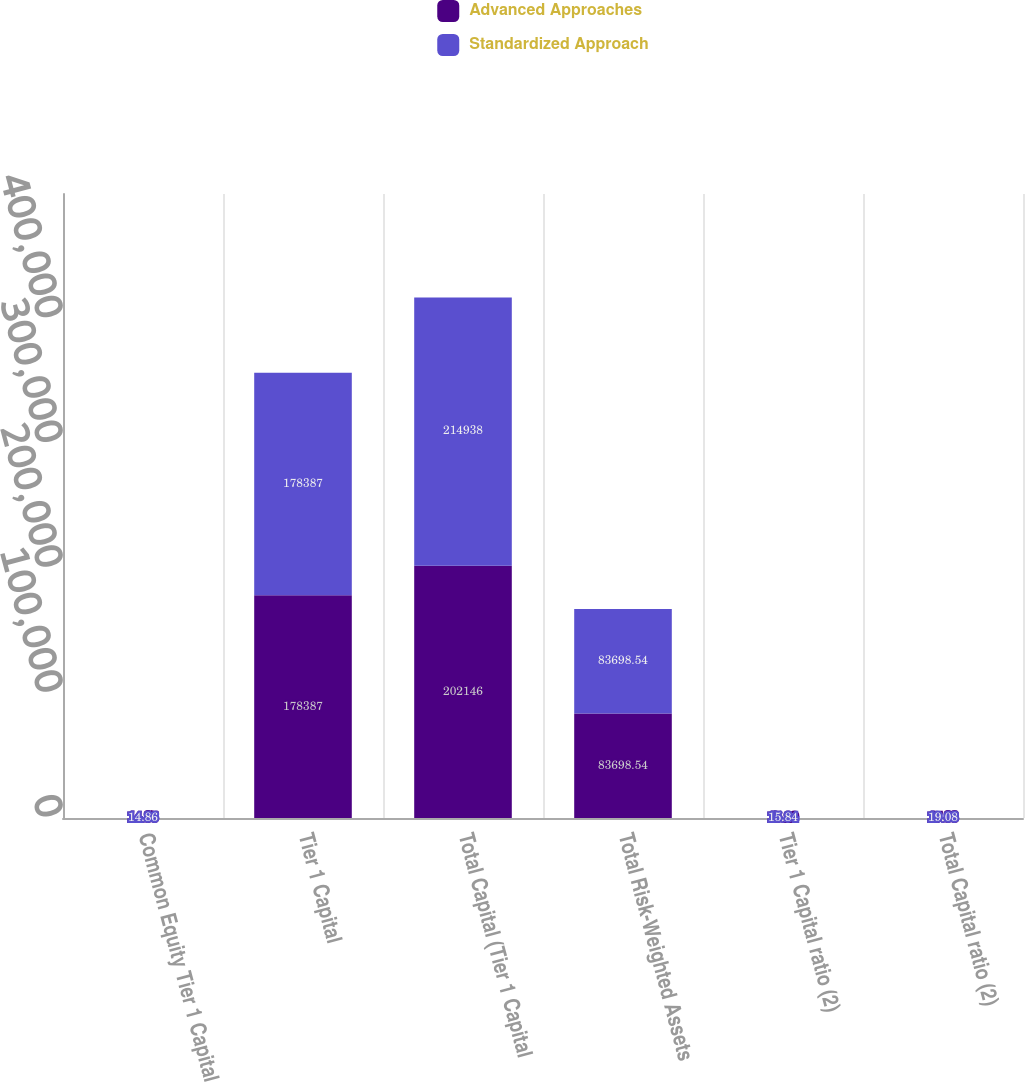<chart> <loc_0><loc_0><loc_500><loc_500><stacked_bar_chart><ecel><fcel>Common Equity Tier 1 Capital<fcel>Tier 1 Capital<fcel>Total Capital (Tier 1 Capital<fcel>Total Risk-Weighted Assets<fcel>Tier 1 Capital ratio (2)<fcel>Total Capital ratio (2)<nl><fcel>Advanced Approaches<fcel>14.35<fcel>178387<fcel>202146<fcel>83698.5<fcel>15.29<fcel>17.33<nl><fcel>Standardized Approach<fcel>14.86<fcel>178387<fcel>214938<fcel>83698.5<fcel>15.84<fcel>19.08<nl></chart> 